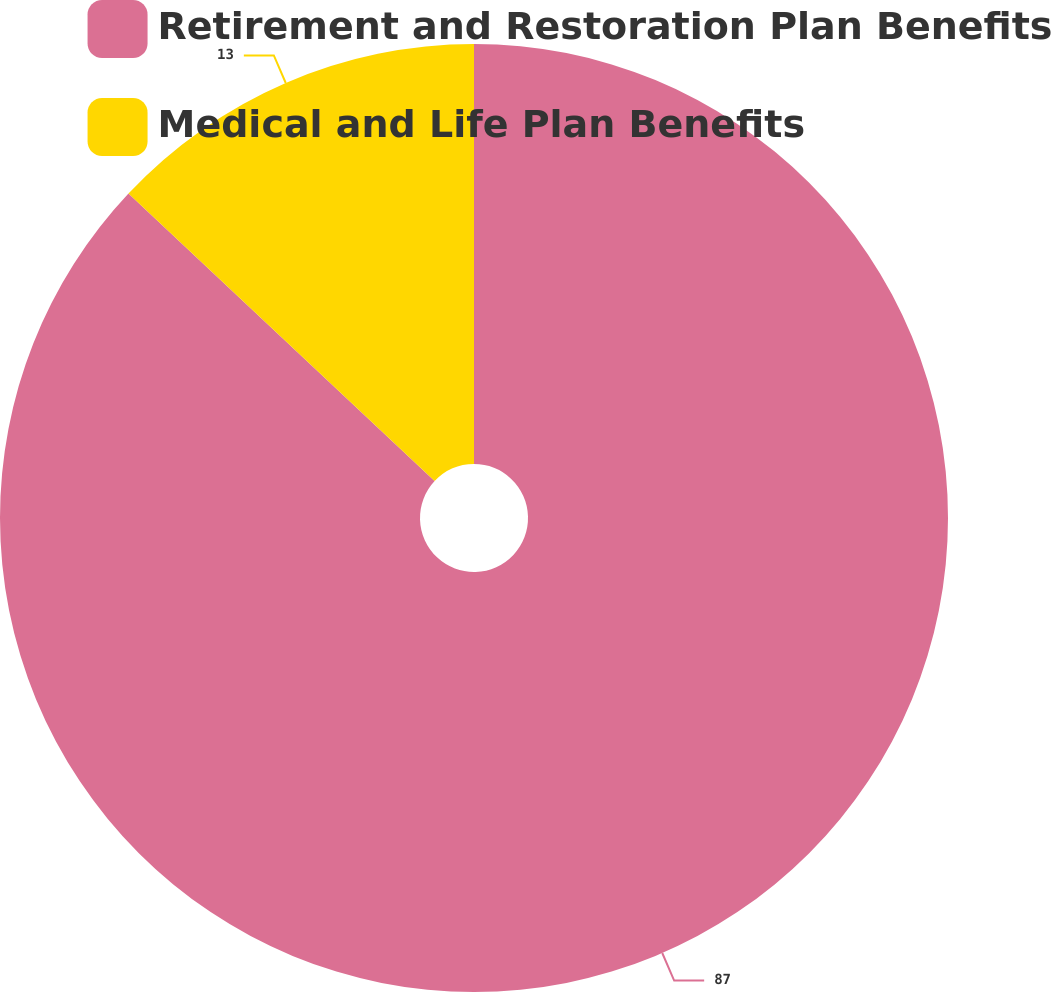<chart> <loc_0><loc_0><loc_500><loc_500><pie_chart><fcel>Retirement and Restoration Plan Benefits<fcel>Medical and Life Plan Benefits<nl><fcel>87.0%<fcel>13.0%<nl></chart> 